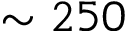Convert formula to latex. <formula><loc_0><loc_0><loc_500><loc_500>\sim 2 5 0</formula> 